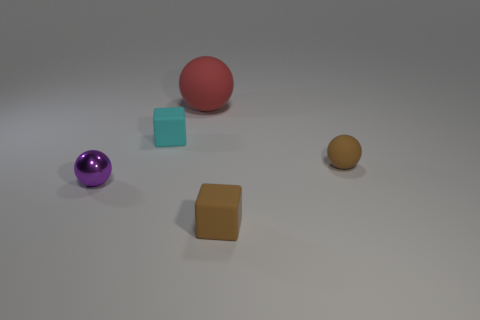Add 1 small cyan objects. How many objects exist? 6 Subtract all blocks. How many objects are left? 3 Add 2 big purple objects. How many big purple objects exist? 2 Subtract 0 brown cylinders. How many objects are left? 5 Subtract all tiny brown cubes. Subtract all red metal cubes. How many objects are left? 4 Add 4 small brown matte objects. How many small brown matte objects are left? 6 